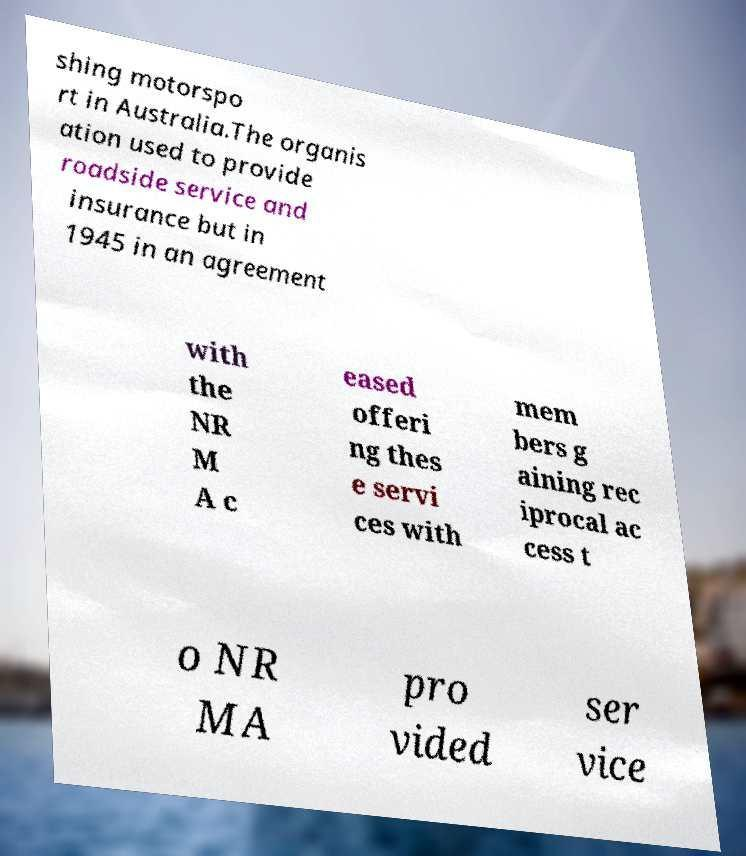Please read and relay the text visible in this image. What does it say? shing motorspo rt in Australia.The organis ation used to provide roadside service and insurance but in 1945 in an agreement with the NR M A c eased offeri ng thes e servi ces with mem bers g aining rec iprocal ac cess t o NR MA pro vided ser vice 